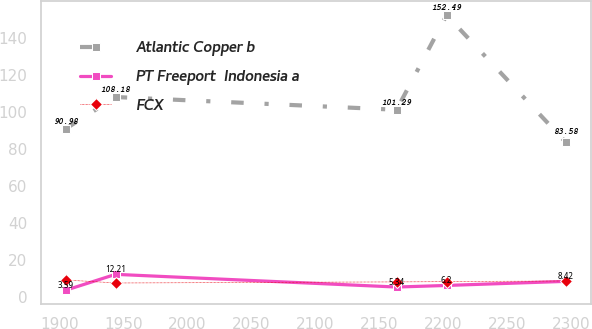<chart> <loc_0><loc_0><loc_500><loc_500><line_chart><ecel><fcel>Atlantic Copper b<fcel>PT Freeport  Indonesia a<fcel>FCX<nl><fcel>1904.87<fcel>90.98<fcel>3.59<fcel>9.18<nl><fcel>1944.01<fcel>108.18<fcel>12.21<fcel>7.54<nl><fcel>2163.76<fcel>101.29<fcel>5.34<fcel>8.13<nl><fcel>2202.9<fcel>152.49<fcel>6.2<fcel>8.29<nl><fcel>2296.28<fcel>83.58<fcel>8.42<fcel>8.62<nl></chart> 